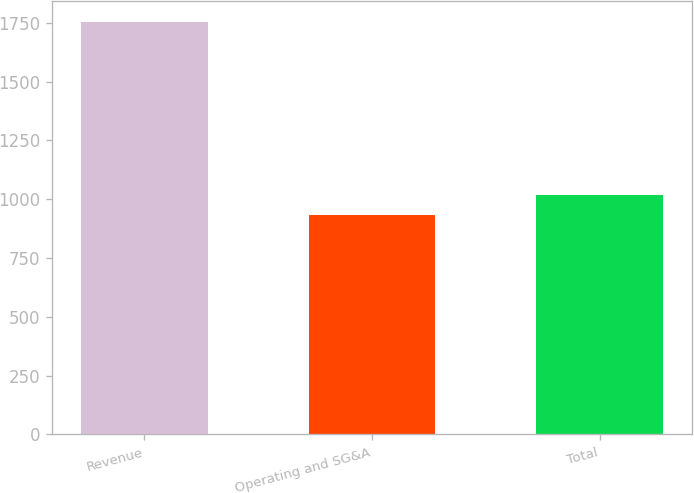Convert chart. <chart><loc_0><loc_0><loc_500><loc_500><bar_chart><fcel>Revenue<fcel>Operating and SG&A<fcel>Total<nl><fcel>1755.4<fcel>934.6<fcel>1016.68<nl></chart> 